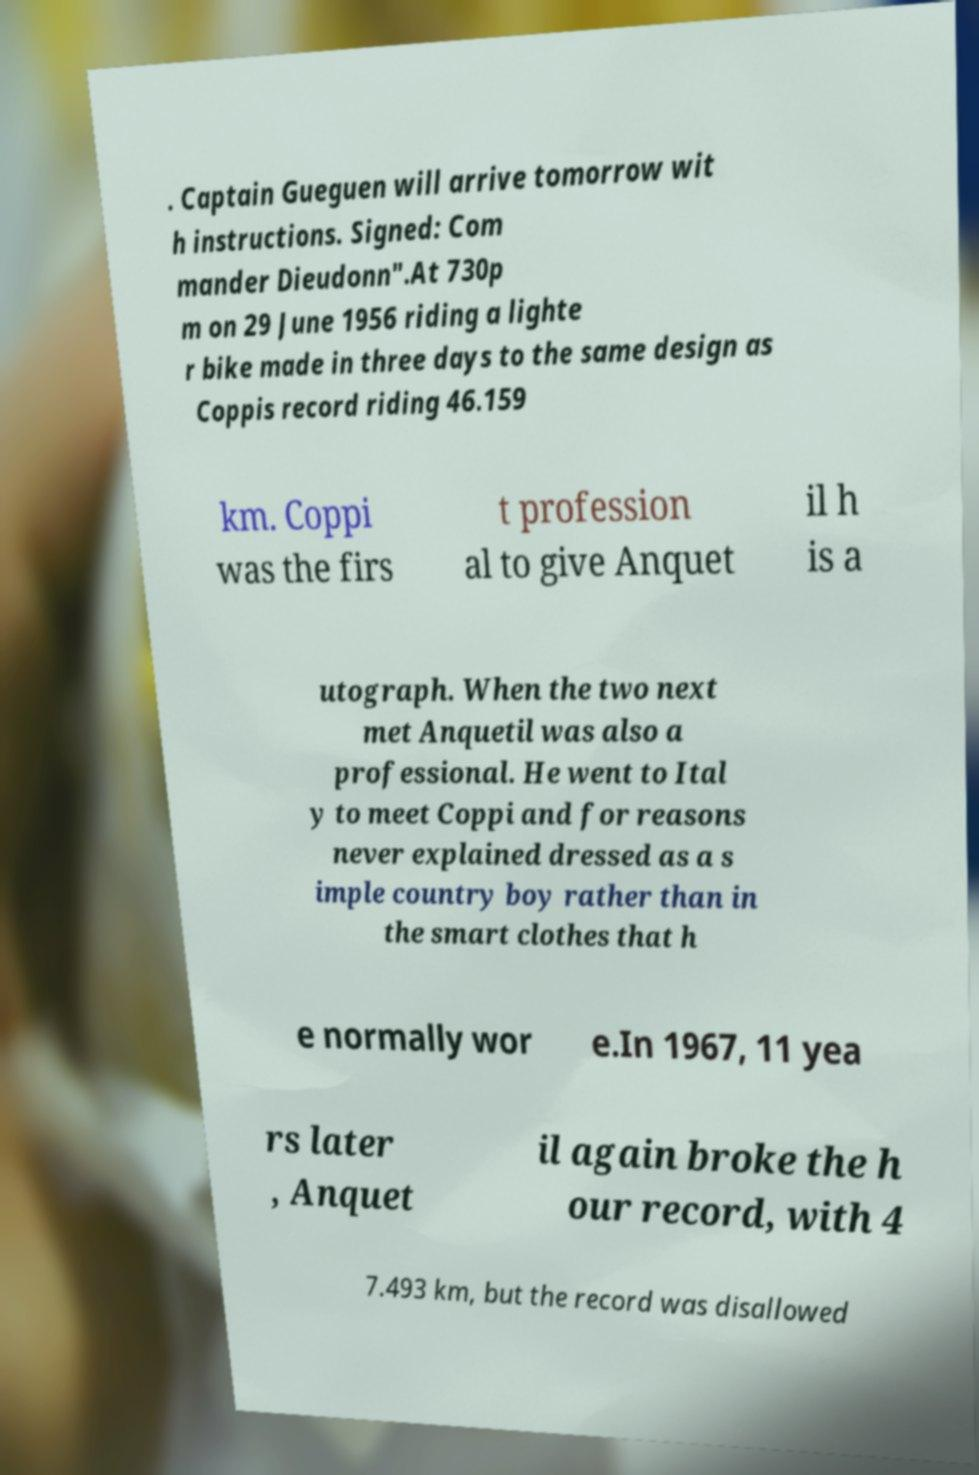Please identify and transcribe the text found in this image. . Captain Gueguen will arrive tomorrow wit h instructions. Signed: Com mander Dieudonn".At 730p m on 29 June 1956 riding a lighte r bike made in three days to the same design as Coppis record riding 46.159 km. Coppi was the firs t profession al to give Anquet il h is a utograph. When the two next met Anquetil was also a professional. He went to Ital y to meet Coppi and for reasons never explained dressed as a s imple country boy rather than in the smart clothes that h e normally wor e.In 1967, 11 yea rs later , Anquet il again broke the h our record, with 4 7.493 km, but the record was disallowed 